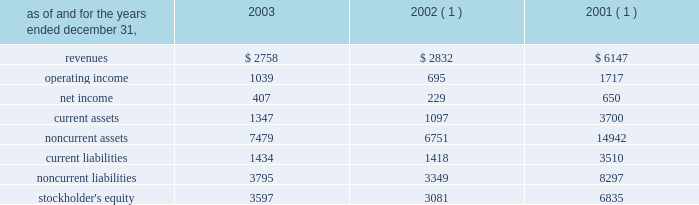In the fourth quarter of 2002 , aes lost voting control of one of the holding companies in the cemig ownership structure .
This holding company indirectly owns the shares related to the cemig investment and indirectly holds the project financing debt related to cemig .
As a result of the loss of voting control , aes stopped consolidating this holding company at december 31 , 2002 .
Other .
During the fourth quarter of 2003 , the company sold its 25% ( 25 % ) ownership interest in medway power limited ( 2018 2018mpl 2019 2019 ) , a 688 mw natural gas-fired combined cycle facility located in the united kingdom , and aes medway operations limited ( 2018 2018aesmo 2019 2019 ) , the operating company for the facility , in an aggregate transaction valued at approximately a347 million ( $ 78 million ) .
The sale resulted in a gain of $ 23 million which was recorded in continuing operations .
Mpl and aesmo were previously reported in the contract generation segment .
In the second quarter of 2002 , the company sold its investment in empresa de infovias s.a .
( 2018 2018infovias 2019 2019 ) , a telecommunications company in brazil , for proceeds of $ 31 million to cemig , an affiliated company .
The loss recorded on the sale was approximately $ 14 million and is recorded as a loss on sale of assets and asset impairment expenses in the accompanying consolidated statements of operations .
In the second quarter of 2002 , the company recorded an impairment charge of approximately $ 40 million , after income taxes , on an equity method investment in a telecommunications company in latin america held by edc .
The impairment charge resulted from sustained poor operating performance coupled with recent funding problems at the invested company .
During 2001 , the company lost operational control of central electricity supply corporation ( 2018 2018cesco 2019 2019 ) , a distribution company located in the state of orissa , india .
The state of orissa appointed an administrator to take operational control of cesco .
Cesco is accounted for as a cost method investment .
Aes 2019s investment in cesco is negative .
In august 2000 , a subsidiary of the company acquired a 49% ( 49 % ) interest in songas for approximately $ 40 million .
The company acquired an additional 16.79% ( 16.79 % ) of songas for approximately $ 12.5 million , and the company began consolidating this entity in 2002 .
Songas owns the songo songo gas-to-electricity project in tanzania .
In december 2002 , the company signed a sales purchase agreement to sell 100% ( 100 % ) of our ownership interest in songas .
The sale of songas closed in april 2003 ( see note 4 for further discussion of the transaction ) .
The tables present summarized comparative financial information ( in millions ) of the entities in which the company has the ability to exercise significant influence but does not control and that are accounted for using the equity method. .
( 1 ) includes information pertaining to eletropaulo and light prior to february 2002 .
In 2002 and 2001 , the results of operations and the financial position of cemig were negatively impacted by the devaluation of the brazilian real and the impairment charge recorded in 2002 .
The brazilian real devalued 32% ( 32 % ) and 19% ( 19 % ) for the years ended december 31 , 2002 and 2001 , respectively. .
In 2003 what are net current assets for entities accounted for using the equity method , in millions? 
Computations: (1347 - 1434)
Answer: -87.0. 